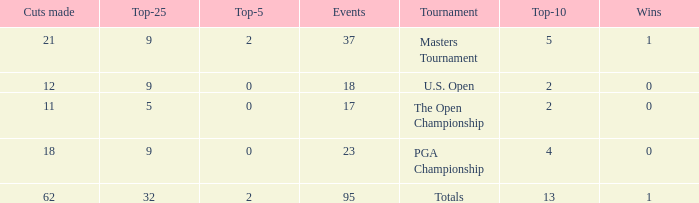Write the full table. {'header': ['Cuts made', 'Top-25', 'Top-5', 'Events', 'Tournament', 'Top-10', 'Wins'], 'rows': [['21', '9', '2', '37', 'Masters Tournament', '5', '1'], ['12', '9', '0', '18', 'U.S. Open', '2', '0'], ['11', '5', '0', '17', 'The Open Championship', '2', '0'], ['18', '9', '0', '23', 'PGA Championship', '4', '0'], ['62', '32', '2', '95', 'Totals', '13', '1']]} What is the number of wins that is in the top 10 and larger than 13? None. 